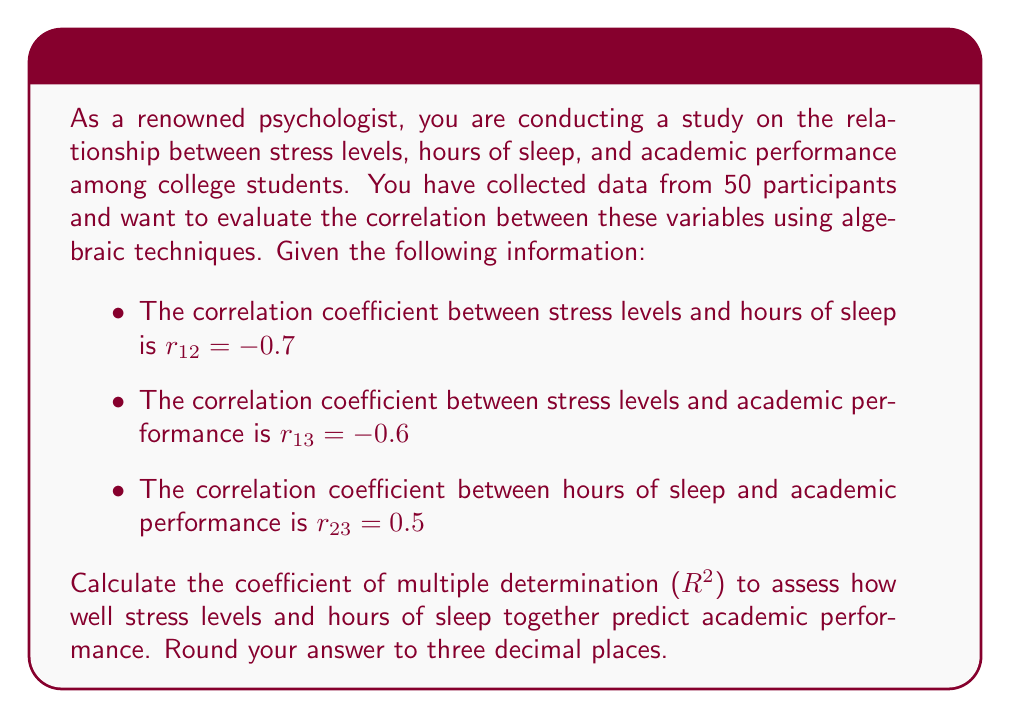Give your solution to this math problem. To solve this problem, we'll use the formula for the coefficient of multiple determination ($R^2$) in a three-variable system:

$$R^2 = \frac{r_{13}^2 + r_{23}^2 - 2r_{12}r_{13}r_{23}}{1 - r_{12}^2}$$

Where:
- $r_{12}$ is the correlation between variables 1 and 2 (stress levels and hours of sleep)
- $r_{13}$ is the correlation between variables 1 and 3 (stress levels and academic performance)
- $r_{23}$ is the correlation between variables 2 and 3 (hours of sleep and academic performance)

Let's substitute the given values:

$$R^2 = \frac{(-0.6)^2 + (0.5)^2 - 2(-0.7)(-0.6)(0.5)}{1 - (-0.7)^2}$$

Now, let's solve step by step:

1. Calculate the numerator:
   $(-0.6)^2 = 0.36$
   $(0.5)^2 = 0.25$
   $2(-0.7)(-0.6)(0.5) = 0.42$
   $0.36 + 0.25 - 0.42 = 0.19$

2. Calculate the denominator:
   $(-0.7)^2 = 0.49$
   $1 - 0.49 = 0.51$

3. Divide the numerator by the denominator:
   $$R^2 = \frac{0.19}{0.51} \approx 0.3725490196$$

4. Round to three decimal places:
   $R^2 \approx 0.373$
Answer: $R^2 \approx 0.373$ 